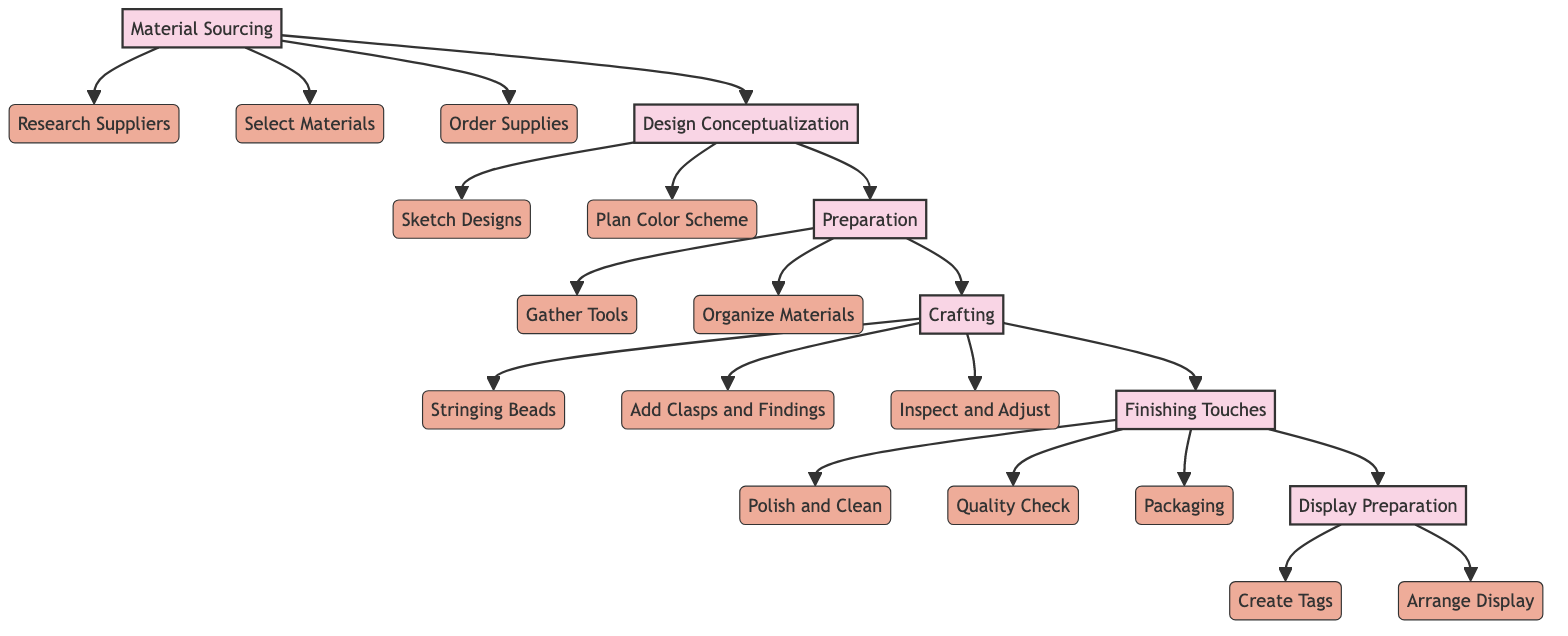What is the first main step in the flowchart? The first main step in the flowchart is "Material Sourcing." This can be determined by looking at the top node of the flowchart, which indicates the initial action taken in creating a handmade necklace.
Answer: Material Sourcing How many substeps are included in the "Crafting" step? The "Crafting" step has three substeps: "Stringing Beads," "Add Clasps and Findings," and "Inspect and Adjust." This can be determined by counting the nodes that branch off from the "Crafting" node.
Answer: 3 What is the last main step represented in the flowchart? The last main step in the flowchart is "Display Preparation." This can be identified by following the sequence of steps, as it is the final node that leads to practical actions regarding displaying the handmade necklace.
Answer: Display Preparation What does the "Quality Check" substep involve? The "Quality Check" substep involves ensuring that all components are securely attached and there are no sharp edges. This detail can be found by looking at the description linked to the "Quality Check" node under the "Finishing Touches" step.
Answer: Ensuring security of components Which step comes after "Preparation"? The step that comes after "Preparation" is "Crafting." This can be confirmed by observing the flow from one main step to the next in the diagram.
Answer: Crafting How many total steps are in the flowchart? The flowchart contains six main steps: "Material Sourcing," "Design Conceptualization," "Preparation," "Crafting," "Finishing Touches," and "Display Preparation." Counting these top-level nodes will provide the total number of steps.
Answer: 6 Which substep falls under the "Finishing Touches"? The "Polish and Clean" substep falls under "Finishing Touches." This is verified by examining the connections leading to the substeps listed under the "Finishing Touches" node.
Answer: Polish and Clean What must be done after "Inspect and Adjust"? "Packaging" must be done after "Inspect and Adjust." This can be determined by following the sequence of actions in the flowchart that move from "Crafting" to "Finishing Touches."
Answer: Packaging Which step involves creating a cohesive color palette? The step that involves creating a cohesive color palette is "Design Conceptualization." This is evident from the connection between the "Design Conceptualization" step and its substep "Plan Color Scheme."
Answer: Design Conceptualization 